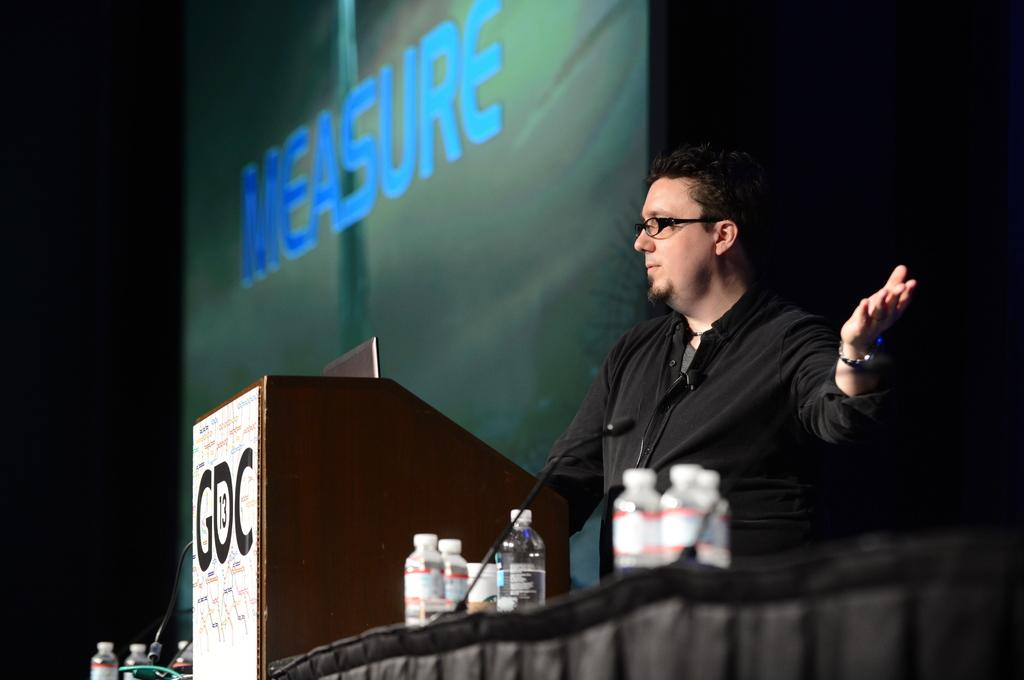What is the person in the image wearing on their face? The person in the image is wearing spectacles. What type of material can be seen in the image? There is cloth visible in the image. What objects are present in the image that might be used for holding liquids? There are bottles in the image. What structure is present in the image that might be used for presentations or speeches? There is a podium in the image. What device is present in the image that might be used for amplifying sound? There is a microphone in the image. What objects in the image might contain written information? There are boards with text in the image. How does the flower contribute to reducing pollution in the image? There is no flower present in the image, so it cannot contribute to reducing pollution. 